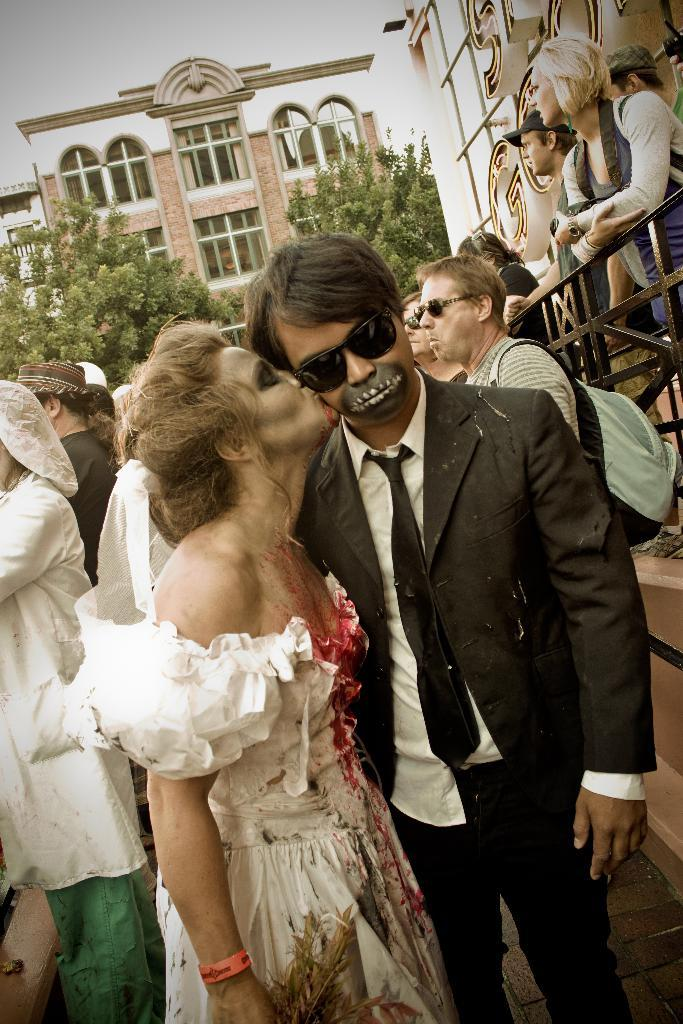How many people are in the image? There is a group of people standing in the image. What objects are visible with the people? Bags and goggles are present in the image. What type of structures can be seen in the image? There are buildings with windows in the image. What type of natural elements are visible in the image? Trees are visible in the image. What is visible in the background of the image? The sky is visible in the background of the image. What type of vessel is being used to transport the yarn in the image? There is no vessel or yarn present in the image. 